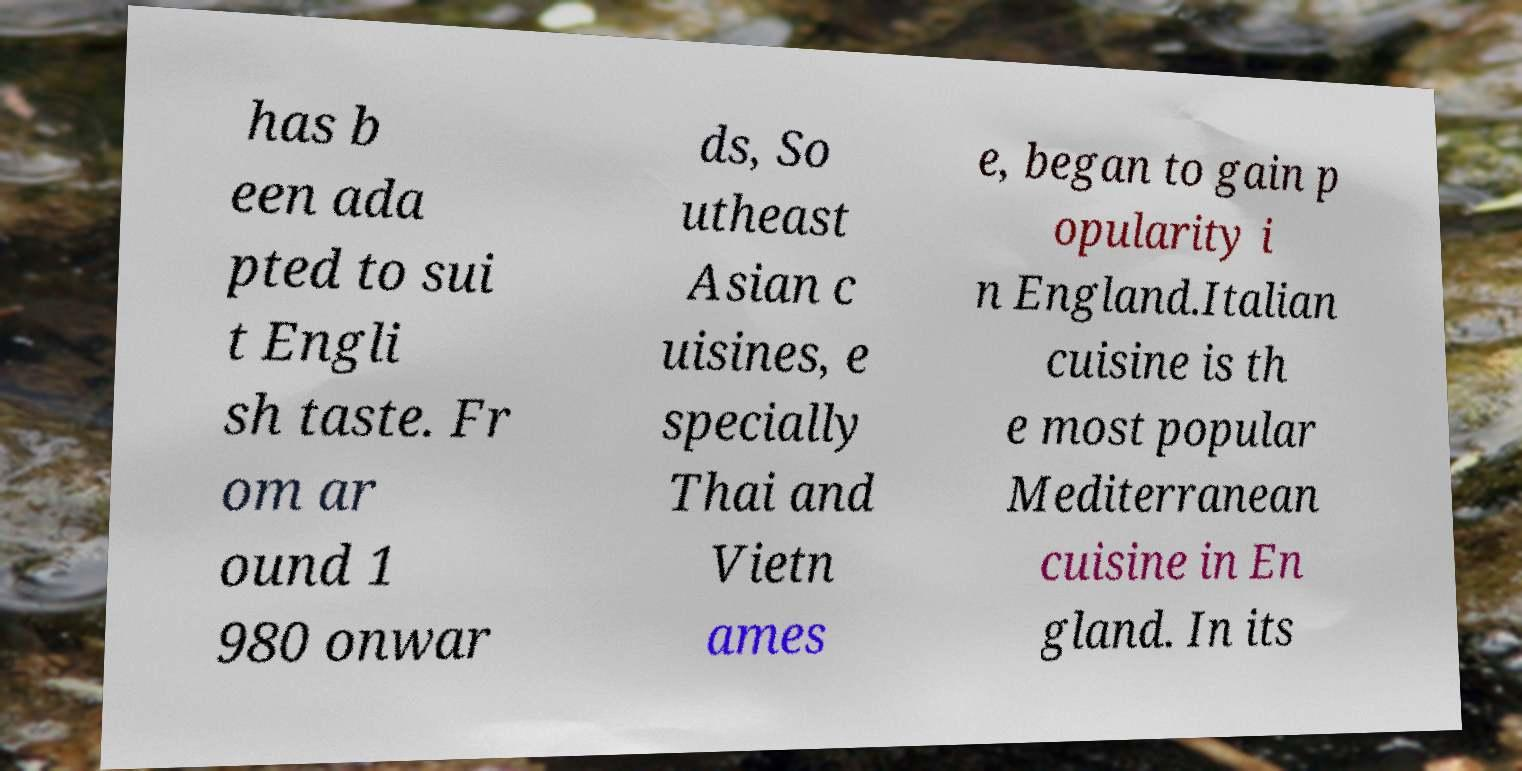For documentation purposes, I need the text within this image transcribed. Could you provide that? has b een ada pted to sui t Engli sh taste. Fr om ar ound 1 980 onwar ds, So utheast Asian c uisines, e specially Thai and Vietn ames e, began to gain p opularity i n England.Italian cuisine is th e most popular Mediterranean cuisine in En gland. In its 